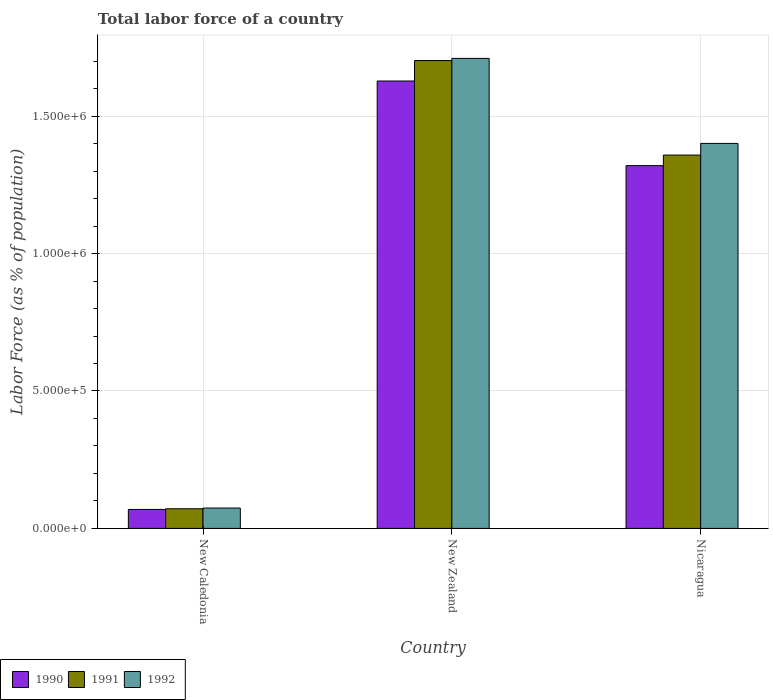Are the number of bars per tick equal to the number of legend labels?
Your answer should be compact. Yes. How many bars are there on the 3rd tick from the left?
Your response must be concise. 3. What is the label of the 3rd group of bars from the left?
Offer a very short reply. Nicaragua. What is the percentage of labor force in 1992 in Nicaragua?
Ensure brevity in your answer.  1.40e+06. Across all countries, what is the maximum percentage of labor force in 1991?
Keep it short and to the point. 1.70e+06. Across all countries, what is the minimum percentage of labor force in 1991?
Offer a terse response. 7.15e+04. In which country was the percentage of labor force in 1992 maximum?
Your response must be concise. New Zealand. In which country was the percentage of labor force in 1990 minimum?
Your answer should be compact. New Caledonia. What is the total percentage of labor force in 1990 in the graph?
Offer a very short reply. 3.02e+06. What is the difference between the percentage of labor force in 1992 in New Caledonia and that in Nicaragua?
Provide a succinct answer. -1.33e+06. What is the difference between the percentage of labor force in 1992 in Nicaragua and the percentage of labor force in 1990 in New Zealand?
Your response must be concise. -2.27e+05. What is the average percentage of labor force in 1991 per country?
Give a very brief answer. 1.04e+06. What is the difference between the percentage of labor force of/in 1990 and percentage of labor force of/in 1991 in Nicaragua?
Offer a very short reply. -3.85e+04. In how many countries, is the percentage of labor force in 1991 greater than 700000 %?
Provide a short and direct response. 2. What is the ratio of the percentage of labor force in 1991 in New Caledonia to that in Nicaragua?
Give a very brief answer. 0.05. Is the percentage of labor force in 1990 in New Caledonia less than that in New Zealand?
Your answer should be very brief. Yes. What is the difference between the highest and the second highest percentage of labor force in 1992?
Your response must be concise. 3.09e+05. What is the difference between the highest and the lowest percentage of labor force in 1990?
Your answer should be compact. 1.56e+06. In how many countries, is the percentage of labor force in 1992 greater than the average percentage of labor force in 1992 taken over all countries?
Provide a succinct answer. 2. What does the 2nd bar from the left in New Caledonia represents?
Your answer should be very brief. 1991. How many bars are there?
Offer a very short reply. 9. Are all the bars in the graph horizontal?
Give a very brief answer. No. What is the difference between two consecutive major ticks on the Y-axis?
Keep it short and to the point. 5.00e+05. Does the graph contain any zero values?
Make the answer very short. No. Does the graph contain grids?
Offer a very short reply. Yes. Where does the legend appear in the graph?
Provide a short and direct response. Bottom left. How many legend labels are there?
Your answer should be very brief. 3. How are the legend labels stacked?
Give a very brief answer. Horizontal. What is the title of the graph?
Your response must be concise. Total labor force of a country. What is the label or title of the Y-axis?
Keep it short and to the point. Labor Force (as % of population). What is the Labor Force (as % of population) of 1990 in New Caledonia?
Make the answer very short. 6.90e+04. What is the Labor Force (as % of population) of 1991 in New Caledonia?
Offer a very short reply. 7.15e+04. What is the Labor Force (as % of population) in 1992 in New Caledonia?
Keep it short and to the point. 7.41e+04. What is the Labor Force (as % of population) of 1990 in New Zealand?
Provide a succinct answer. 1.63e+06. What is the Labor Force (as % of population) of 1991 in New Zealand?
Offer a terse response. 1.70e+06. What is the Labor Force (as % of population) of 1992 in New Zealand?
Ensure brevity in your answer.  1.71e+06. What is the Labor Force (as % of population) in 1990 in Nicaragua?
Your answer should be compact. 1.32e+06. What is the Labor Force (as % of population) in 1991 in Nicaragua?
Provide a short and direct response. 1.36e+06. What is the Labor Force (as % of population) of 1992 in Nicaragua?
Keep it short and to the point. 1.40e+06. Across all countries, what is the maximum Labor Force (as % of population) in 1990?
Ensure brevity in your answer.  1.63e+06. Across all countries, what is the maximum Labor Force (as % of population) in 1991?
Offer a terse response. 1.70e+06. Across all countries, what is the maximum Labor Force (as % of population) in 1992?
Give a very brief answer. 1.71e+06. Across all countries, what is the minimum Labor Force (as % of population) in 1990?
Ensure brevity in your answer.  6.90e+04. Across all countries, what is the minimum Labor Force (as % of population) in 1991?
Offer a terse response. 7.15e+04. Across all countries, what is the minimum Labor Force (as % of population) of 1992?
Offer a very short reply. 7.41e+04. What is the total Labor Force (as % of population) in 1990 in the graph?
Give a very brief answer. 3.02e+06. What is the total Labor Force (as % of population) in 1991 in the graph?
Ensure brevity in your answer.  3.13e+06. What is the total Labor Force (as % of population) in 1992 in the graph?
Your response must be concise. 3.19e+06. What is the difference between the Labor Force (as % of population) of 1990 in New Caledonia and that in New Zealand?
Provide a succinct answer. -1.56e+06. What is the difference between the Labor Force (as % of population) in 1991 in New Caledonia and that in New Zealand?
Provide a short and direct response. -1.63e+06. What is the difference between the Labor Force (as % of population) in 1992 in New Caledonia and that in New Zealand?
Make the answer very short. -1.64e+06. What is the difference between the Labor Force (as % of population) of 1990 in New Caledonia and that in Nicaragua?
Your answer should be very brief. -1.25e+06. What is the difference between the Labor Force (as % of population) of 1991 in New Caledonia and that in Nicaragua?
Give a very brief answer. -1.29e+06. What is the difference between the Labor Force (as % of population) in 1992 in New Caledonia and that in Nicaragua?
Offer a terse response. -1.33e+06. What is the difference between the Labor Force (as % of population) of 1990 in New Zealand and that in Nicaragua?
Offer a very short reply. 3.08e+05. What is the difference between the Labor Force (as % of population) of 1991 in New Zealand and that in Nicaragua?
Keep it short and to the point. 3.44e+05. What is the difference between the Labor Force (as % of population) in 1992 in New Zealand and that in Nicaragua?
Provide a succinct answer. 3.09e+05. What is the difference between the Labor Force (as % of population) in 1990 in New Caledonia and the Labor Force (as % of population) in 1991 in New Zealand?
Make the answer very short. -1.63e+06. What is the difference between the Labor Force (as % of population) in 1990 in New Caledonia and the Labor Force (as % of population) in 1992 in New Zealand?
Give a very brief answer. -1.64e+06. What is the difference between the Labor Force (as % of population) of 1991 in New Caledonia and the Labor Force (as % of population) of 1992 in New Zealand?
Your response must be concise. -1.64e+06. What is the difference between the Labor Force (as % of population) of 1990 in New Caledonia and the Labor Force (as % of population) of 1991 in Nicaragua?
Provide a succinct answer. -1.29e+06. What is the difference between the Labor Force (as % of population) of 1990 in New Caledonia and the Labor Force (as % of population) of 1992 in Nicaragua?
Offer a very short reply. -1.33e+06. What is the difference between the Labor Force (as % of population) in 1991 in New Caledonia and the Labor Force (as % of population) in 1992 in Nicaragua?
Your answer should be very brief. -1.33e+06. What is the difference between the Labor Force (as % of population) of 1990 in New Zealand and the Labor Force (as % of population) of 1991 in Nicaragua?
Your response must be concise. 2.69e+05. What is the difference between the Labor Force (as % of population) in 1990 in New Zealand and the Labor Force (as % of population) in 1992 in Nicaragua?
Ensure brevity in your answer.  2.27e+05. What is the difference between the Labor Force (as % of population) in 1991 in New Zealand and the Labor Force (as % of population) in 1992 in Nicaragua?
Offer a very short reply. 3.01e+05. What is the average Labor Force (as % of population) of 1990 per country?
Provide a succinct answer. 1.01e+06. What is the average Labor Force (as % of population) in 1991 per country?
Your answer should be compact. 1.04e+06. What is the average Labor Force (as % of population) in 1992 per country?
Ensure brevity in your answer.  1.06e+06. What is the difference between the Labor Force (as % of population) in 1990 and Labor Force (as % of population) in 1991 in New Caledonia?
Ensure brevity in your answer.  -2456. What is the difference between the Labor Force (as % of population) in 1990 and Labor Force (as % of population) in 1992 in New Caledonia?
Your response must be concise. -5044. What is the difference between the Labor Force (as % of population) in 1991 and Labor Force (as % of population) in 1992 in New Caledonia?
Provide a short and direct response. -2588. What is the difference between the Labor Force (as % of population) of 1990 and Labor Force (as % of population) of 1991 in New Zealand?
Ensure brevity in your answer.  -7.44e+04. What is the difference between the Labor Force (as % of population) in 1990 and Labor Force (as % of population) in 1992 in New Zealand?
Offer a terse response. -8.23e+04. What is the difference between the Labor Force (as % of population) in 1991 and Labor Force (as % of population) in 1992 in New Zealand?
Your answer should be very brief. -7943. What is the difference between the Labor Force (as % of population) in 1990 and Labor Force (as % of population) in 1991 in Nicaragua?
Keep it short and to the point. -3.85e+04. What is the difference between the Labor Force (as % of population) in 1990 and Labor Force (as % of population) in 1992 in Nicaragua?
Provide a short and direct response. -8.09e+04. What is the difference between the Labor Force (as % of population) of 1991 and Labor Force (as % of population) of 1992 in Nicaragua?
Provide a succinct answer. -4.24e+04. What is the ratio of the Labor Force (as % of population) of 1990 in New Caledonia to that in New Zealand?
Your answer should be compact. 0.04. What is the ratio of the Labor Force (as % of population) of 1991 in New Caledonia to that in New Zealand?
Make the answer very short. 0.04. What is the ratio of the Labor Force (as % of population) in 1992 in New Caledonia to that in New Zealand?
Your answer should be compact. 0.04. What is the ratio of the Labor Force (as % of population) of 1990 in New Caledonia to that in Nicaragua?
Your answer should be very brief. 0.05. What is the ratio of the Labor Force (as % of population) in 1991 in New Caledonia to that in Nicaragua?
Your answer should be very brief. 0.05. What is the ratio of the Labor Force (as % of population) in 1992 in New Caledonia to that in Nicaragua?
Your answer should be compact. 0.05. What is the ratio of the Labor Force (as % of population) in 1990 in New Zealand to that in Nicaragua?
Make the answer very short. 1.23. What is the ratio of the Labor Force (as % of population) of 1991 in New Zealand to that in Nicaragua?
Give a very brief answer. 1.25. What is the ratio of the Labor Force (as % of population) of 1992 in New Zealand to that in Nicaragua?
Give a very brief answer. 1.22. What is the difference between the highest and the second highest Labor Force (as % of population) in 1990?
Make the answer very short. 3.08e+05. What is the difference between the highest and the second highest Labor Force (as % of population) of 1991?
Keep it short and to the point. 3.44e+05. What is the difference between the highest and the second highest Labor Force (as % of population) of 1992?
Offer a terse response. 3.09e+05. What is the difference between the highest and the lowest Labor Force (as % of population) in 1990?
Ensure brevity in your answer.  1.56e+06. What is the difference between the highest and the lowest Labor Force (as % of population) of 1991?
Your answer should be compact. 1.63e+06. What is the difference between the highest and the lowest Labor Force (as % of population) of 1992?
Keep it short and to the point. 1.64e+06. 